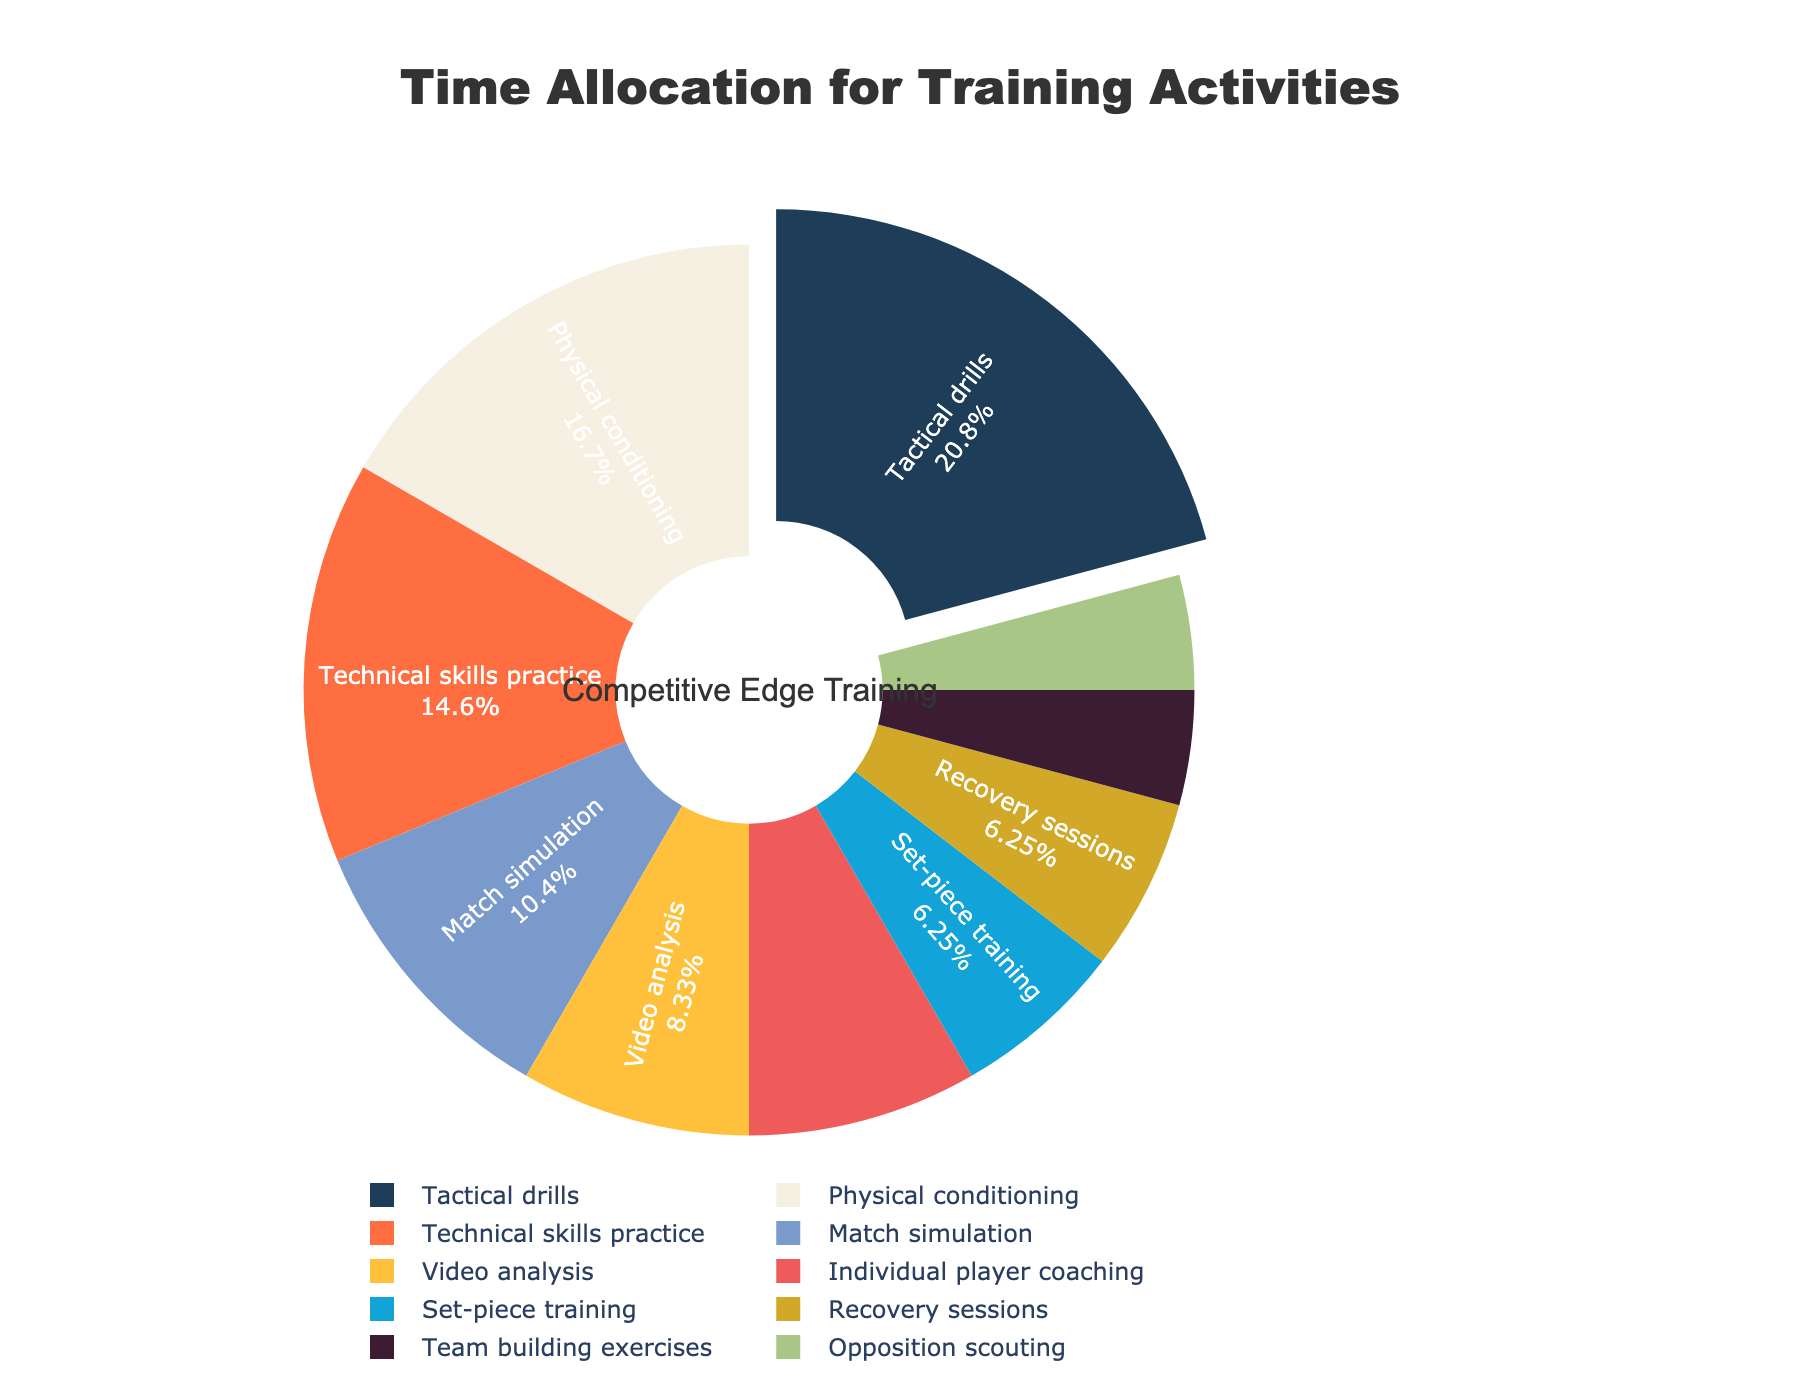What's the largest slice of the pie chart? The largest slice represents the activity that takes the most hours in a typical week. From the data provided, Tactical drills take 10 hours, which is the maximum.
Answer: Tactical drills Which activity takes up the least amount of time? The smallest slice represents the activity with the fewest hours. According to the data, Team building exercises and Opposition scouting both take 2 hours, the minimum number of hours.
Answer: Team building exercises and Opposition scouting How much time is allocated to Match simulation compared to Technical skills practice? To compare the time, look at the hours dedicated to each activity. Match simulation has 5 hours and Technical skills practice has 7 hours. Thus, Match simulation takes 2 hours less than Technical skills practice.
Answer: 2 hours less What percentage of the total training time is dedicated to Physical conditioning? The percentage is represented visually in the pie chart. To calculate it, divide the hours for Physical conditioning (8) by the total hours (48) and multiply by 100. This is approximately 16.67%.
Answer: 16.67% What is the total number of hours spent on Recovery sessions, Set-piece training, and Individual player coaching combined? Add the hours for Recovery sessions (3), Set-piece training (3), and Individual player coaching (4). This sums up to 10 hours.
Answer: 10 hours Which activities have equal time allocations? The equal slices on the pie chart represent activities with identical hours. According to the data, Set-piece training and Recovery sessions both have 3 hours each.
Answer: Set-piece training and Recovery sessions How much more time is spent on Video analysis compared to Opposition scouting? Calculate the difference between the hours for Video analysis (4) and Opposition scouting (2). The difference is 2 hours.
Answer: 2 hours What is the share of total time for activities related to game strategy (Tactical drills, Video analysis, Set-piece training, Match simulation, Opposition scouting)? Sum the hours for these activities (Tactical drills: 10, Video analysis: 4, Set-piece training: 3, Match simulation: 5, Opposition scouting: 2). The total is 24 hours. Then, divide by the total hours (48) and multiply by 100 to get the percentage, which is 50%.
Answer: 50% Compare the time spent on Physical conditioning and Technical skills practice. Which one takes more hours and by how much? Physical conditioning has 8 hours, and Technical skills practice has 7 hours. Therefore, Physical conditioning takes 1 hour more.
Answer: Physical conditioning takes 1 hour more What proportion of the pie chart is dedicated to Team building exercises? The proportion can be found by dividing the hours dedicated to Team building exercises (2) by the total hours (48). Thus, approximately 4.17% of the pie chart is dedicated to Team building exercises.
Answer: 4.17% 